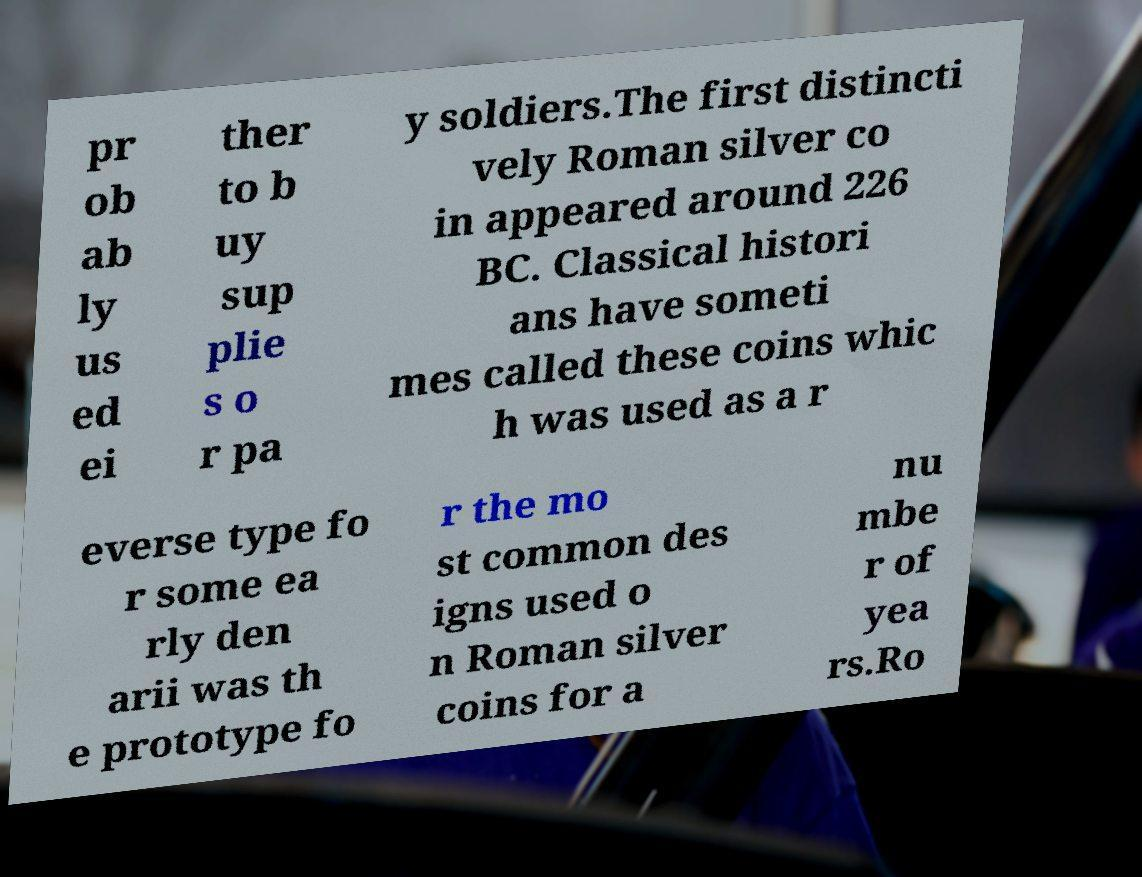Please read and relay the text visible in this image. What does it say? pr ob ab ly us ed ei ther to b uy sup plie s o r pa y soldiers.The first distincti vely Roman silver co in appeared around 226 BC. Classical histori ans have someti mes called these coins whic h was used as a r everse type fo r some ea rly den arii was th e prototype fo r the mo st common des igns used o n Roman silver coins for a nu mbe r of yea rs.Ro 